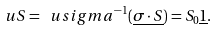<formula> <loc_0><loc_0><loc_500><loc_500>\ u S = \ u s i g m a ^ { - 1 } ( \underline { \sigma \cdot S } ) = S _ { 0 } \underline { 1 } .</formula> 